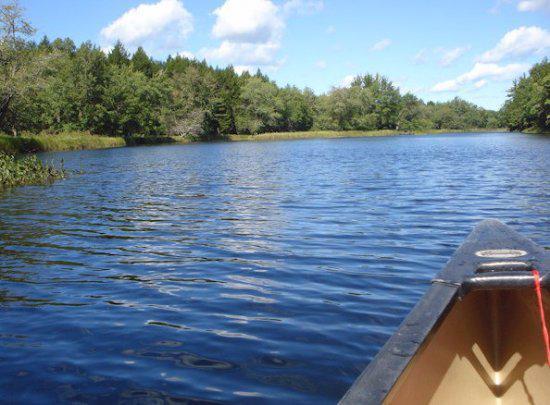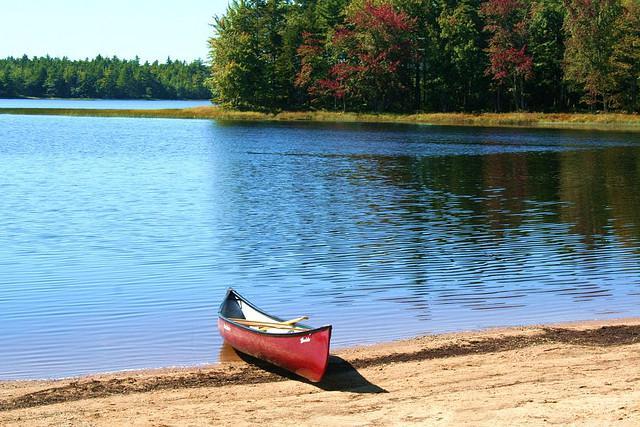The first image is the image on the left, the second image is the image on the right. Examine the images to the left and right. Is the description "There is more than one boat in the image on the right." accurate? Answer yes or no. No. 